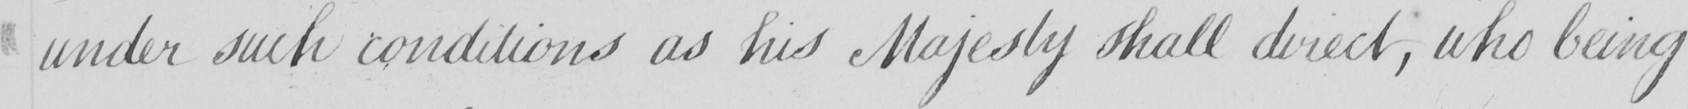Can you tell me what this handwritten text says? under such conditions as his Majesty shall direct , who being 